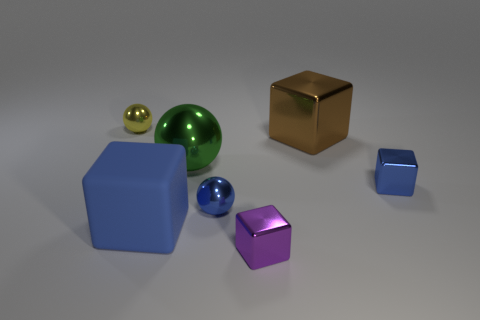There is a rubber cube; is its size the same as the blue metal object that is to the left of the small purple object?
Your response must be concise. No. How many shiny objects are large green blocks or green things?
Your answer should be compact. 1. Are there more small shiny objects than metallic things?
Provide a succinct answer. No. What is the size of the metallic block that is the same color as the large matte cube?
Offer a terse response. Small. What is the shape of the small thing that is behind the thing that is to the right of the big brown shiny cube?
Offer a very short reply. Sphere. There is a blue metallic object that is behind the tiny ball that is in front of the tiny yellow metallic ball; are there any blue shiny things that are in front of it?
Offer a very short reply. Yes. There is another cube that is the same size as the brown block; what is its color?
Offer a very short reply. Blue. What shape is the object that is both on the right side of the yellow thing and behind the green metallic ball?
Give a very brief answer. Cube. There is a blue cube to the right of the tiny ball that is in front of the tiny yellow metal sphere; what size is it?
Provide a succinct answer. Small. How many small objects have the same color as the large matte cube?
Provide a short and direct response. 2. 